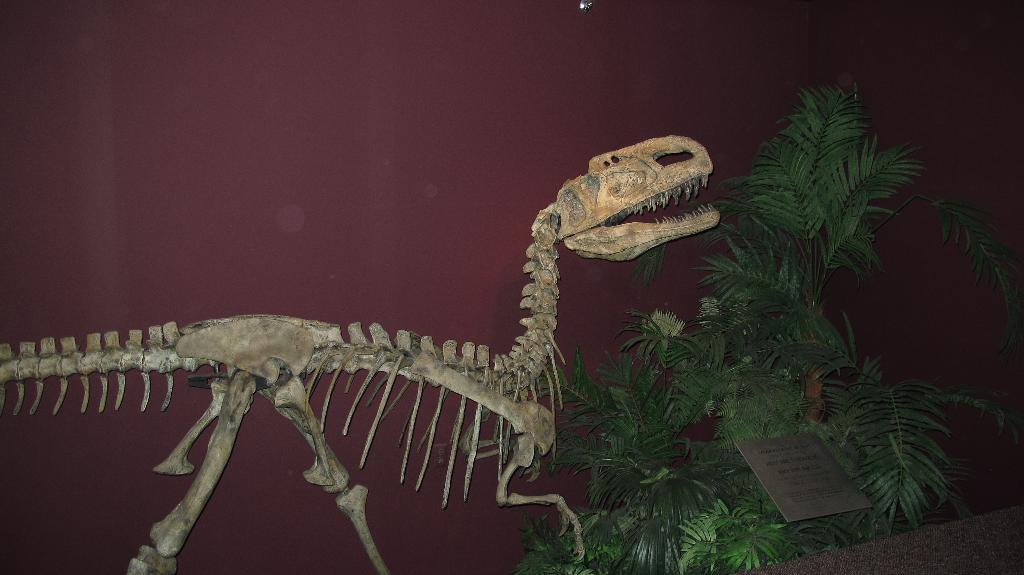What is the main subject of the image? There is a dinosaur skeleton in the image. What is located on the right side of the skeleton? There is a board and a tree on the right side of the skeleton. What can be seen behind the skeleton? There appears to be a wall behind the skeleton. What type of square riddle can be seen on the tree in the image? There is no square riddle present in the image; the tree is a natural element in the background. 